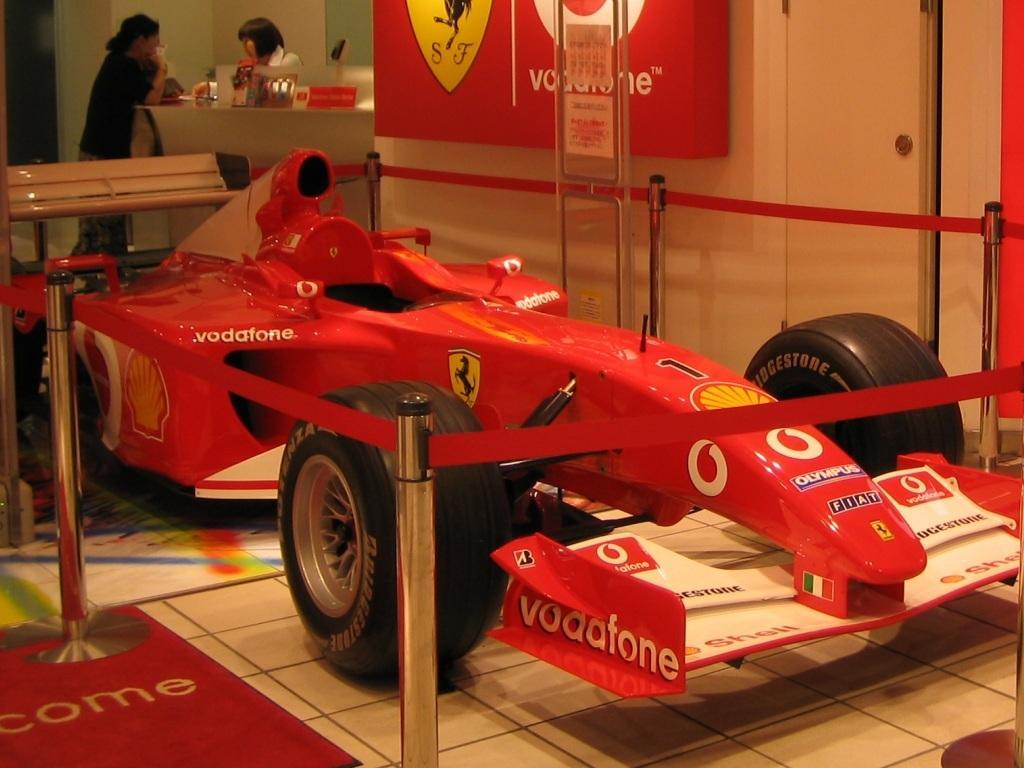How would you summarize this image in a sentence or two? In this picture, we see a red color sports car. Beside that, we see the barrier poles. At the bottom, we see the floor and a carpet in red color. On the left side, we see a bench and two women are standing. In front of them, we see a table on which a name board and the objects are placed. In the background, we see a white wall and a board in white, yellow and red color with some text written on it. 